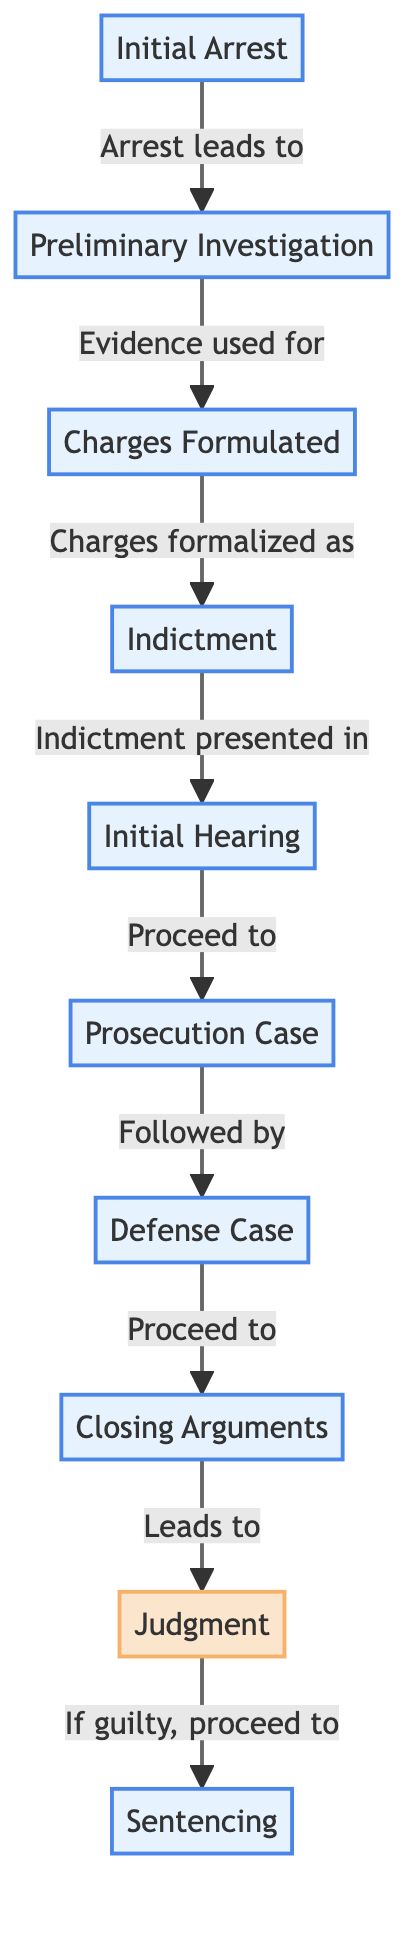What is the first step in the Nuremberg Trials process? The diagram indicates that the first node in the flowchart is "Initial Arrest," which is the beginning of the process. Therefore, the initial step starts with the arrest of individuals.
Answer: Initial Arrest How many total steps are there in the Nuremberg Trials process? The diagram consists of ten distinct nodes, each representing a key step in the Nuremberg Trials process. By counting these nodes, we find there are a total of ten steps.
Answer: Ten What happens after the "Charges Formulated"? The flowchart indicates that after "Charges Formulated," the next step is the "Indictment." Therefore, the process proceeds with the formal presentation of charges through an indictment.
Answer: Indictment Which two steps are followed after "Closing Arguments"? According to the flowchart, the step following "Closing Arguments" is "Judgment," and if the judgment is guilty, the next step would be "Sentencing." Thus, both "Judgment" and "Sentencing" are the subsequent steps.
Answer: Judgment, Sentencing What is the relationship between "Preliminary Investigation" and "Charges Formulated"? The flowchart indicates an arrow from "Preliminary Investigation" to "Charges Formulated," which shows that the preliminary investigation provides the evidence needed to formalize charges. This relationship establishes a cause-and-effect linking these two stages.
Answer: Evidence used for charges If the verdict is guilty, what is the final step? The diagram shows that following the "Judgment," if the decision is guilty, it leads to "Sentencing." Therefore, the final step based on this condition is the sentencing phase of the trial process.
Answer: Sentencing What type of node is "Judgment" classified as? Within the flowchart, the "Judgment" node is specifically identified under the classification of a decision node, which is indicated by its unique styling specifically labeled as decision in the flowchart.
Answer: Decision What connects the "Initial Hearing" to the "Prosecution Case"? The diagram presents a direct arrow from "Initial Hearing" leading to "Prosecution Case," indicating that the initial hearing phase allows for the progression to presenting the prosecution's case in court. This connection signifies the flow of proceedings within the trial process.
Answer: Proceed to Prosecution Case 